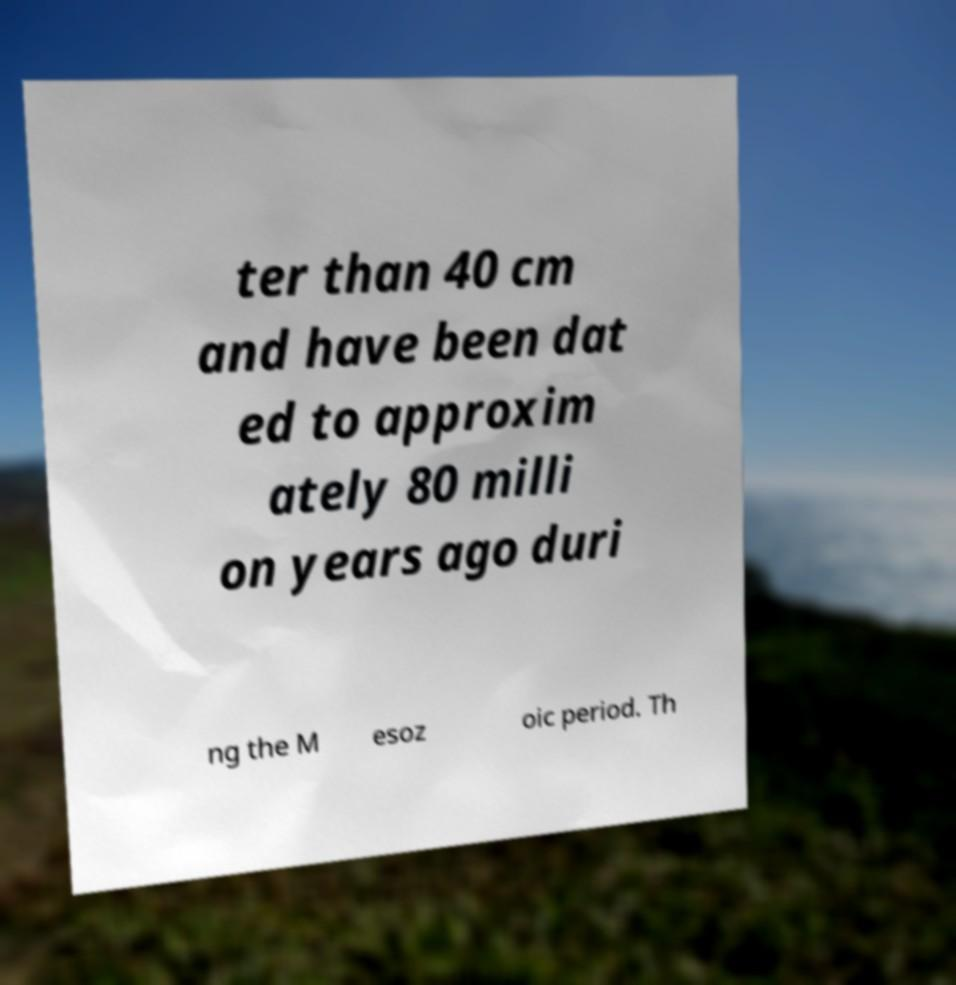For documentation purposes, I need the text within this image transcribed. Could you provide that? ter than 40 cm and have been dat ed to approxim ately 80 milli on years ago duri ng the M esoz oic period. Th 